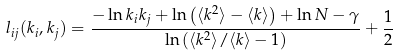<formula> <loc_0><loc_0><loc_500><loc_500>l _ { i j } ( k _ { i } , k _ { j } ) = \frac { - \ln k _ { i } k _ { j } + \ln \left ( \langle k ^ { 2 } \rangle - \langle k \rangle \right ) + \ln N - \gamma } { \ln \left ( \langle k ^ { 2 } \rangle / \langle k \rangle - 1 \right ) } + \frac { 1 } { 2 }</formula> 